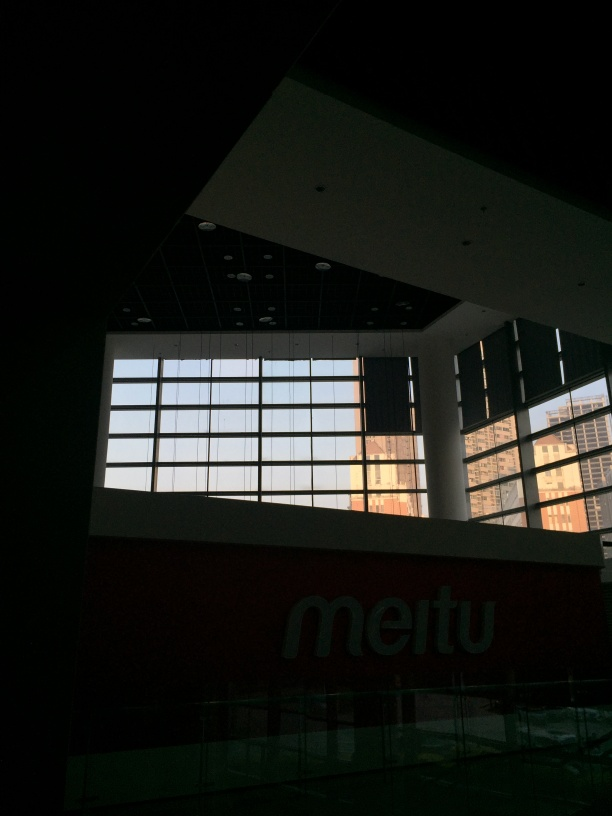What are the issues with the focus of the image? The image appears to have focusing issues; the lower interior segment, including the signage, is not in sharp focus, which could be due to a shallow depth of field or camera movement. The window area is better illuminated, yet it doesn't show crisp edges or details, possibly due to backlighting, suggesting that the focus isn't perfect throughout. 